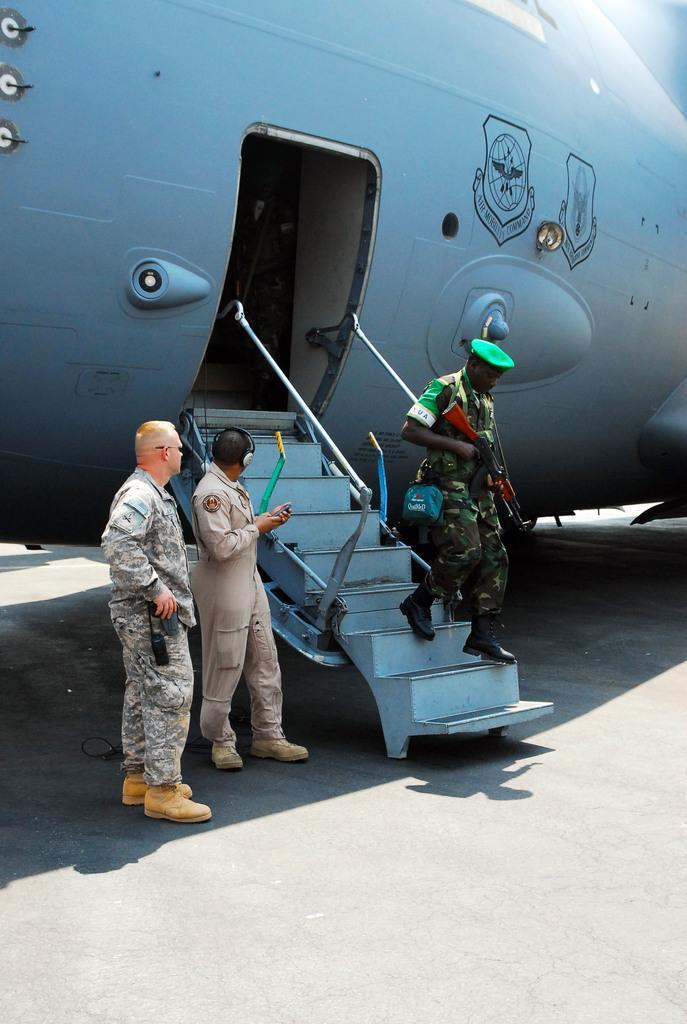Can you describe this image briefly? In this picture there is a cop, by holding a gun in his hand, on the stairs of an air craft and there are two people on the left side of the image. 